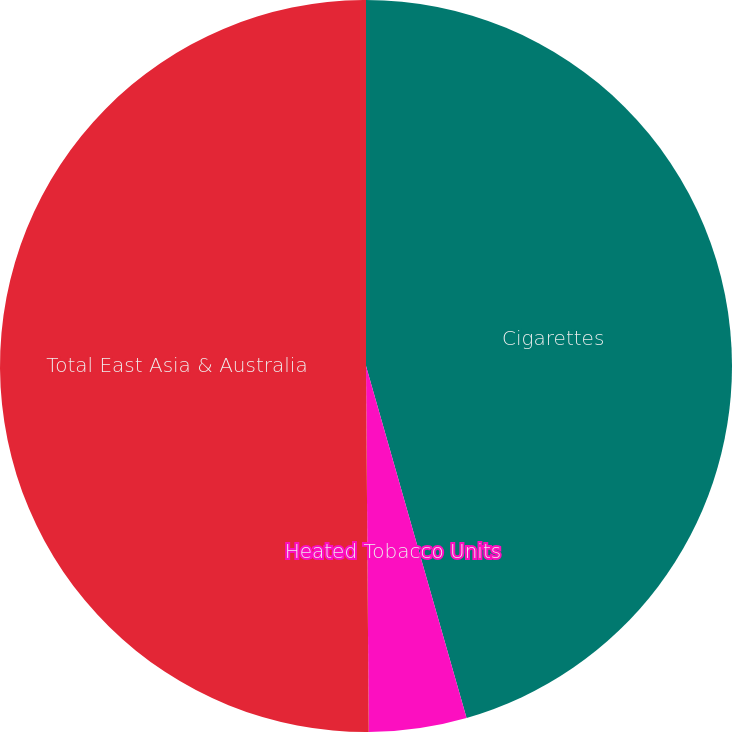Convert chart. <chart><loc_0><loc_0><loc_500><loc_500><pie_chart><fcel>Cigarettes<fcel>Heated Tobacco Units<fcel>Total East Asia & Australia<nl><fcel>45.57%<fcel>4.31%<fcel>50.12%<nl></chart> 